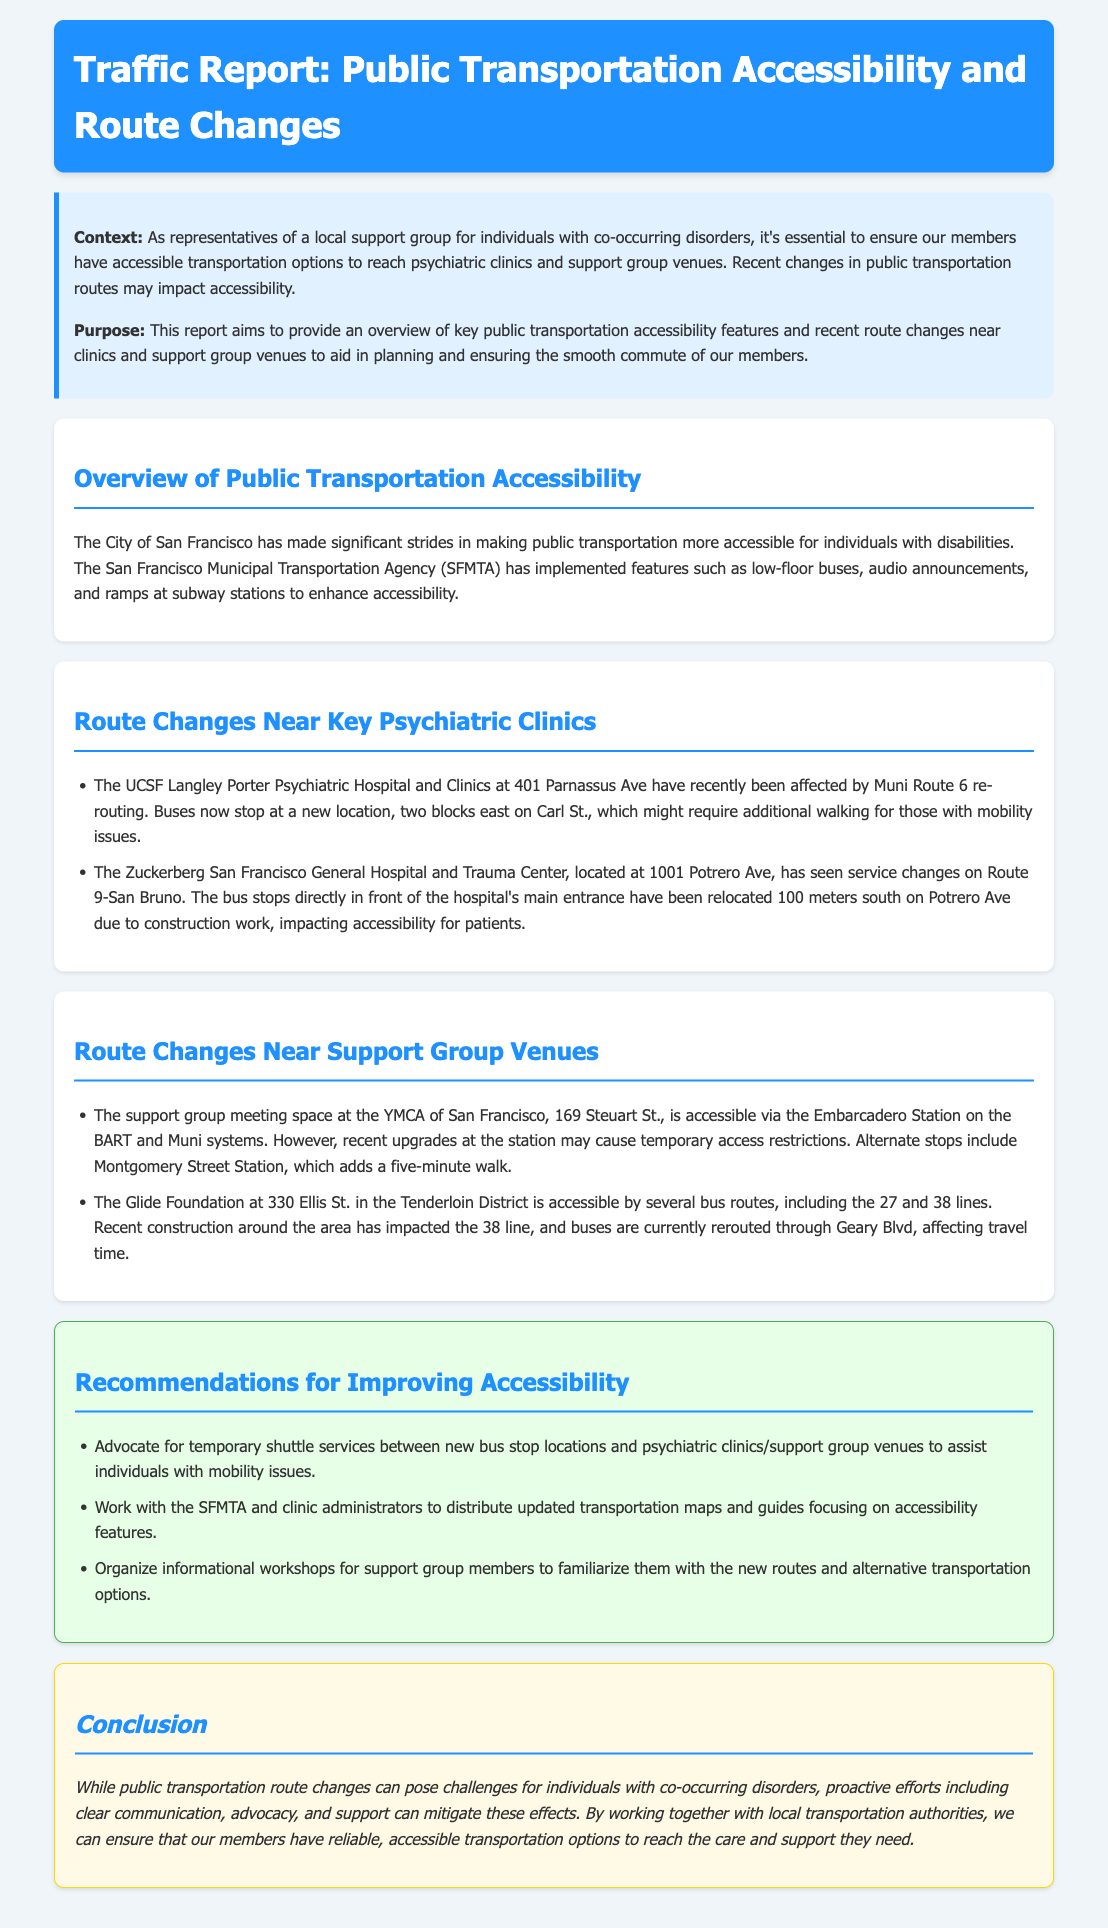What is the title of the report? The title appears in the header section and identifies the focus of the report on transportation accessibility and route changes.
Answer: Traffic Report: Public Transportation Accessibility and Route Changes What is the location of the UCSF Langley Porter Psychiatric Hospital? This information is specified in the section discussing route changes near psychiatric clinics, detailing the clinic's address for context.
Answer: 401 Parnassus Ave Which bus line has been rerouted at Zuckerberg San Francisco General Hospital? The bus line affected by the recent service changes is mentioned in the route changes section concerning this hospital.
Answer: Route 9-San Bruno How far has the bus stop been relocated from the main entrance of Zuckerberg San Francisco General Hospital? This detail is provided in the document, describing the specific distance to highlight the impact of the route change.
Answer: 100 meters What is a suggested recommendation to improve accessibility? The recommendations section lists various suggestions to enhance transportation for individuals with mobility issues.
Answer: Advocate for temporary shuttle services Name one alternate BART station for accessing the YMCA of San Francisco. The document mentions alternate stations available due to upgrades at Embarcadero Station in the section about route changes near support group venues.
Answer: Montgomery Street Station What recent impact is noted regarding the Glide Foundation's accessibility? This impact is identified under route changes near support group venues, explaining how construction has affected services.
Answer: The 38 line has been rerouted Why is clear communication important according to the conclusion? This is discussed in the document's conclusion, emphasizing a proactive approach in addressing transportation challenges for members.
Answer: To mitigate effects of route changes 